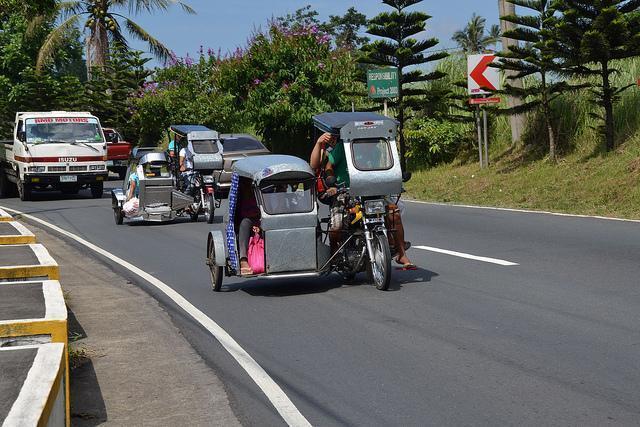How many bikes are shown?
Give a very brief answer. 2. How many lights are on the front of the motorcycle?
Give a very brief answer. 1. How many chairs are visible?
Give a very brief answer. 0. 